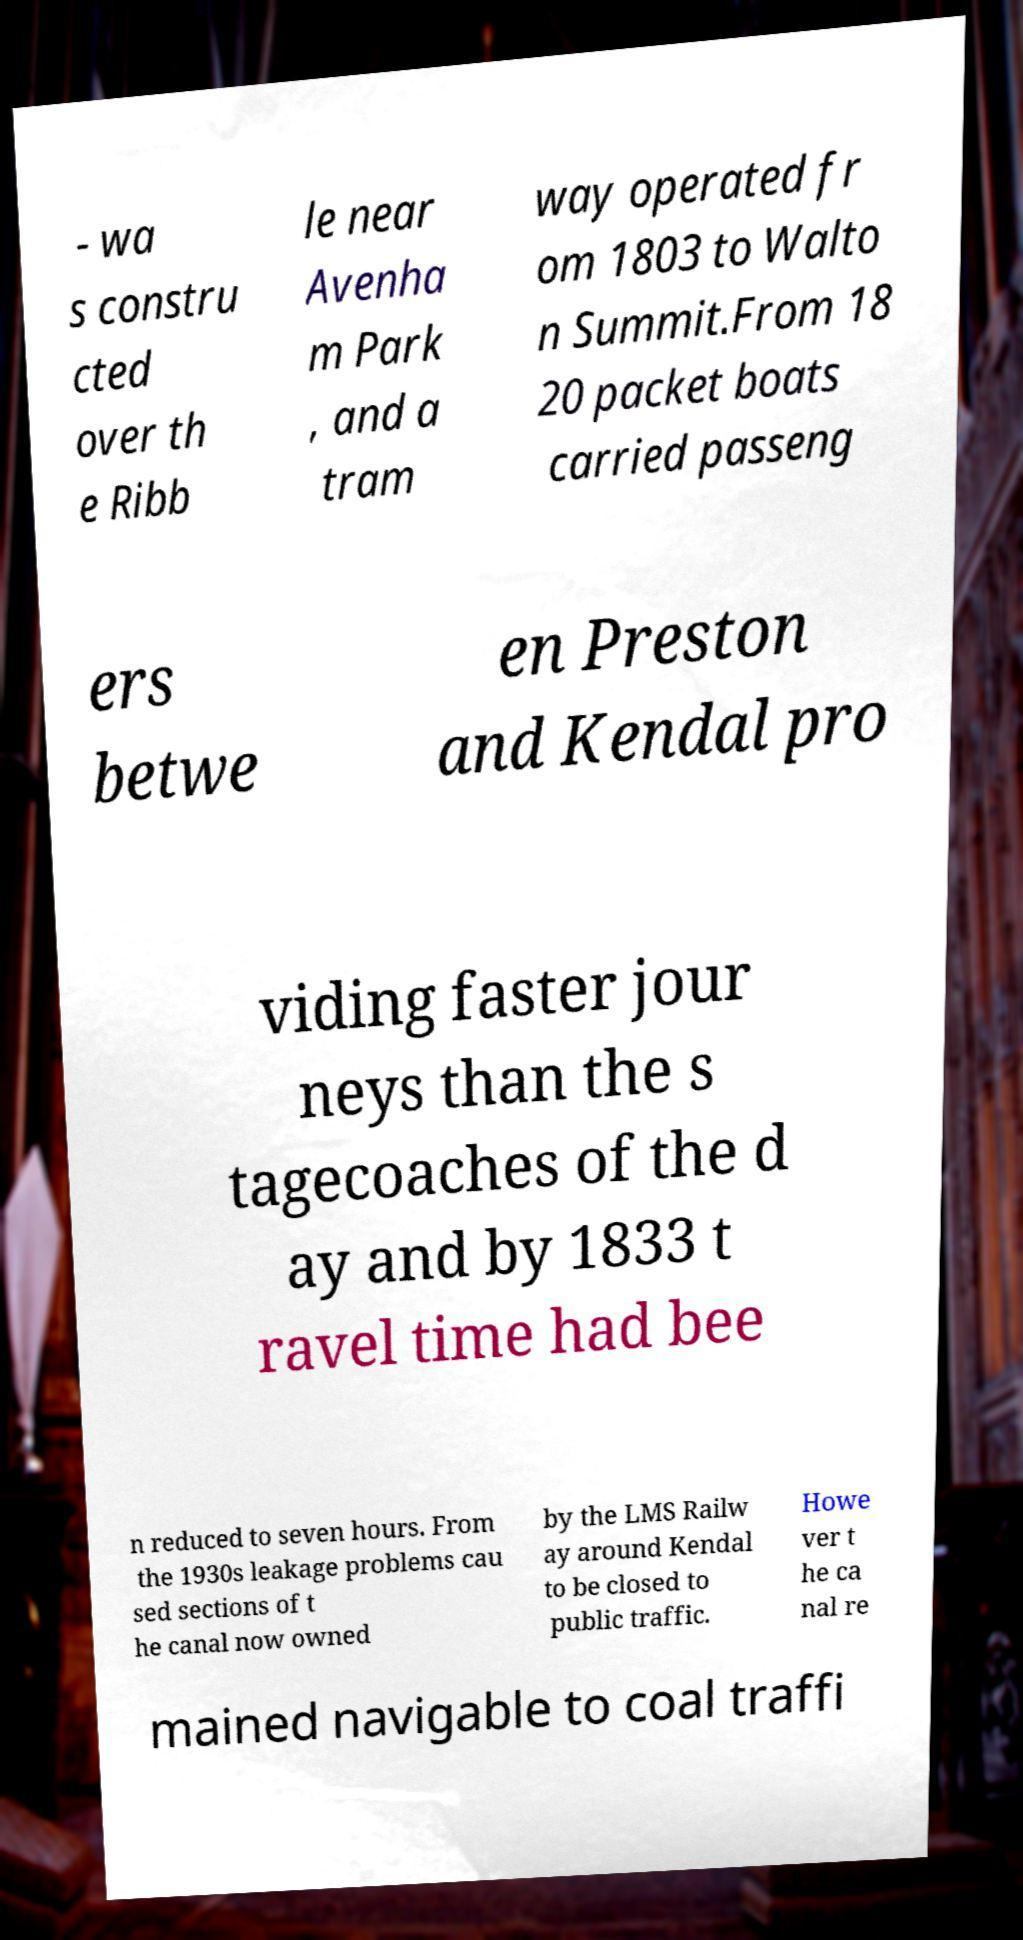I need the written content from this picture converted into text. Can you do that? - wa s constru cted over th e Ribb le near Avenha m Park , and a tram way operated fr om 1803 to Walto n Summit.From 18 20 packet boats carried passeng ers betwe en Preston and Kendal pro viding faster jour neys than the s tagecoaches of the d ay and by 1833 t ravel time had bee n reduced to seven hours. From the 1930s leakage problems cau sed sections of t he canal now owned by the LMS Railw ay around Kendal to be closed to public traffic. Howe ver t he ca nal re mained navigable to coal traffi 